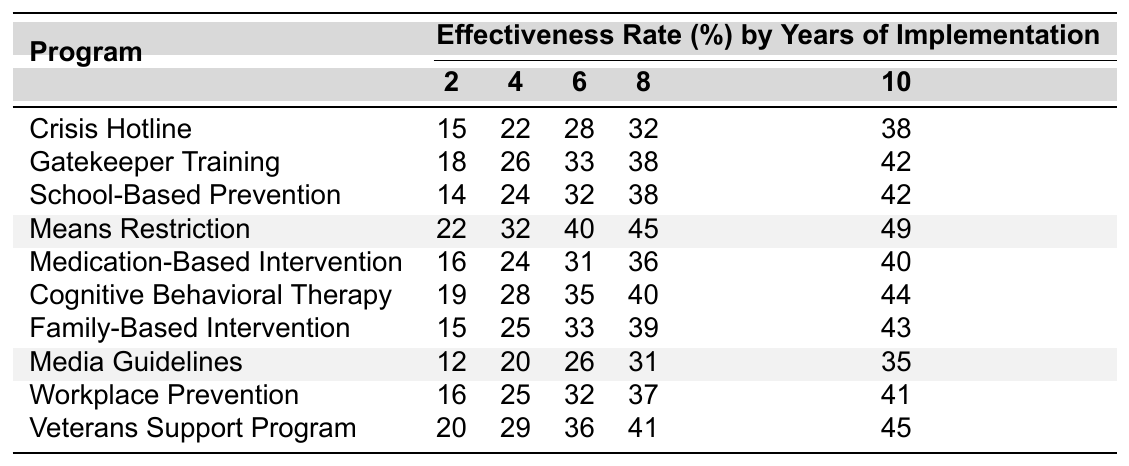What is the effectiveness rate of the Crisis Hotline after 4 years of implementation? From the table, the effectiveness rate for the Crisis Hotline after 4 years is listed under the 4-year column, which shows a value of 22.
Answer: 22 Which program has the highest effectiveness rate after 10 years? At the 10-year mark, the effectiveness rates of the programs are compared. The Means Restriction has the highest rate at 49.
Answer: Means Restriction What is the average effectiveness rate of the Cognitive Behavioral Therapy program across all years? The rates for Cognitive Behavioral Therapy across 2, 4, 6, 8, and 10 years are 19, 28, 35, 40, and 44. Summing these gives 166, which divided by 5 results in an average of 33.2.
Answer: 33.2 Is the effectiveness rate of the Veterans Support Program greater than 40% at any point? By checking the effectiveness rates for the Veterans Support Program across years, the values are 20, 29, 36, 41, and 45. The values 41 and 45 are both greater than 40, making the statement true.
Answer: Yes What is the difference in effectiveness rates between the Gatekeeper Training and the Means Restriction after 6 years? The effectiveness rate for Gatekeeper Training at 6 years is 33, while for Means Restriction, it is 40. The difference is calculated as 40 - 33 = 7.
Answer: 7 Which program shows the least improvement in effectiveness from 2 years to 10 years? The program with the least improvement can be found by calculating the differences for each program from the 2-year to the 10-year mark. After evaluating, the School-Based Prevention improves by only 28 (10-year) - 14 (2-year) = 14.
Answer: School-Based Prevention How many programs have an effectiveness rate of 30% or more after 8 years? Looking at the 8-year effectiveness rates, the values are 32, 38, 38, 45, 36, 40, 39, 31, 37, and 41. Counting those 30% and above results in 7 programs.
Answer: 7 What is the trend in effectiveness rates for the Means Restriction program? Analyzing the effectiveness rates of Means Restriction at each year (22, 32, 40, 45, 49) shows consistent growth year-over-year, indicating a positive trend.
Answer: Positive trend 